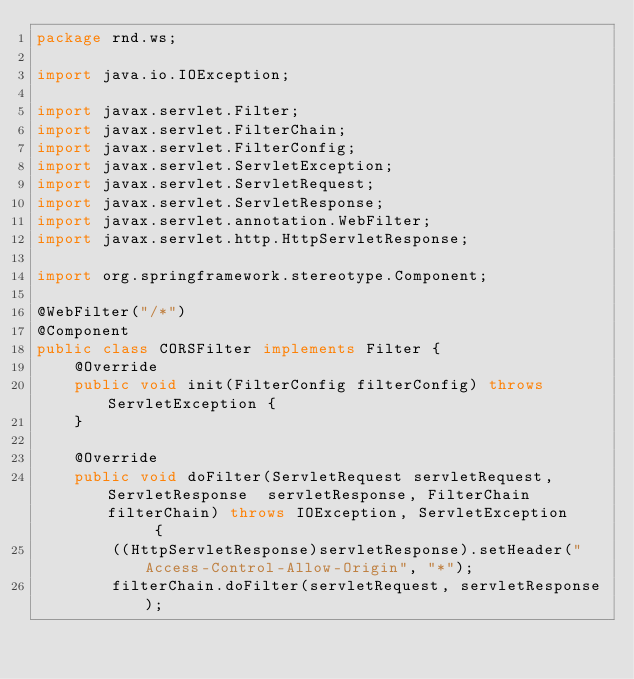<code> <loc_0><loc_0><loc_500><loc_500><_Java_>package rnd.ws;

import java.io.IOException;

import javax.servlet.Filter;
import javax.servlet.FilterChain;
import javax.servlet.FilterConfig;
import javax.servlet.ServletException;
import javax.servlet.ServletRequest;
import javax.servlet.ServletResponse;
import javax.servlet.annotation.WebFilter;
import javax.servlet.http.HttpServletResponse;

import org.springframework.stereotype.Component;

@WebFilter("/*")
@Component
public class CORSFilter implements Filter {
    @Override
    public void init(FilterConfig filterConfig) throws ServletException {
    }

    @Override
    public void doFilter(ServletRequest servletRequest, ServletResponse  servletResponse, FilterChain filterChain) throws IOException, ServletException      {
        ((HttpServletResponse)servletResponse).setHeader("Access-Control-Allow-Origin", "*");
        filterChain.doFilter(servletRequest, servletResponse);</code> 